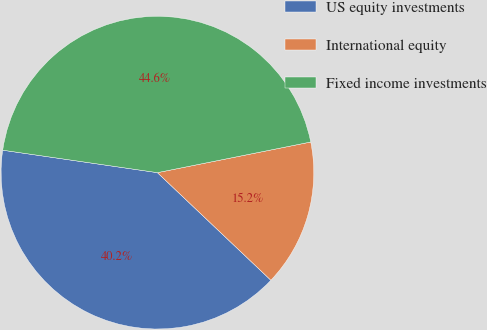<chart> <loc_0><loc_0><loc_500><loc_500><pie_chart><fcel>US equity investments<fcel>International equity<fcel>Fixed income investments<nl><fcel>40.22%<fcel>15.22%<fcel>44.57%<nl></chart> 